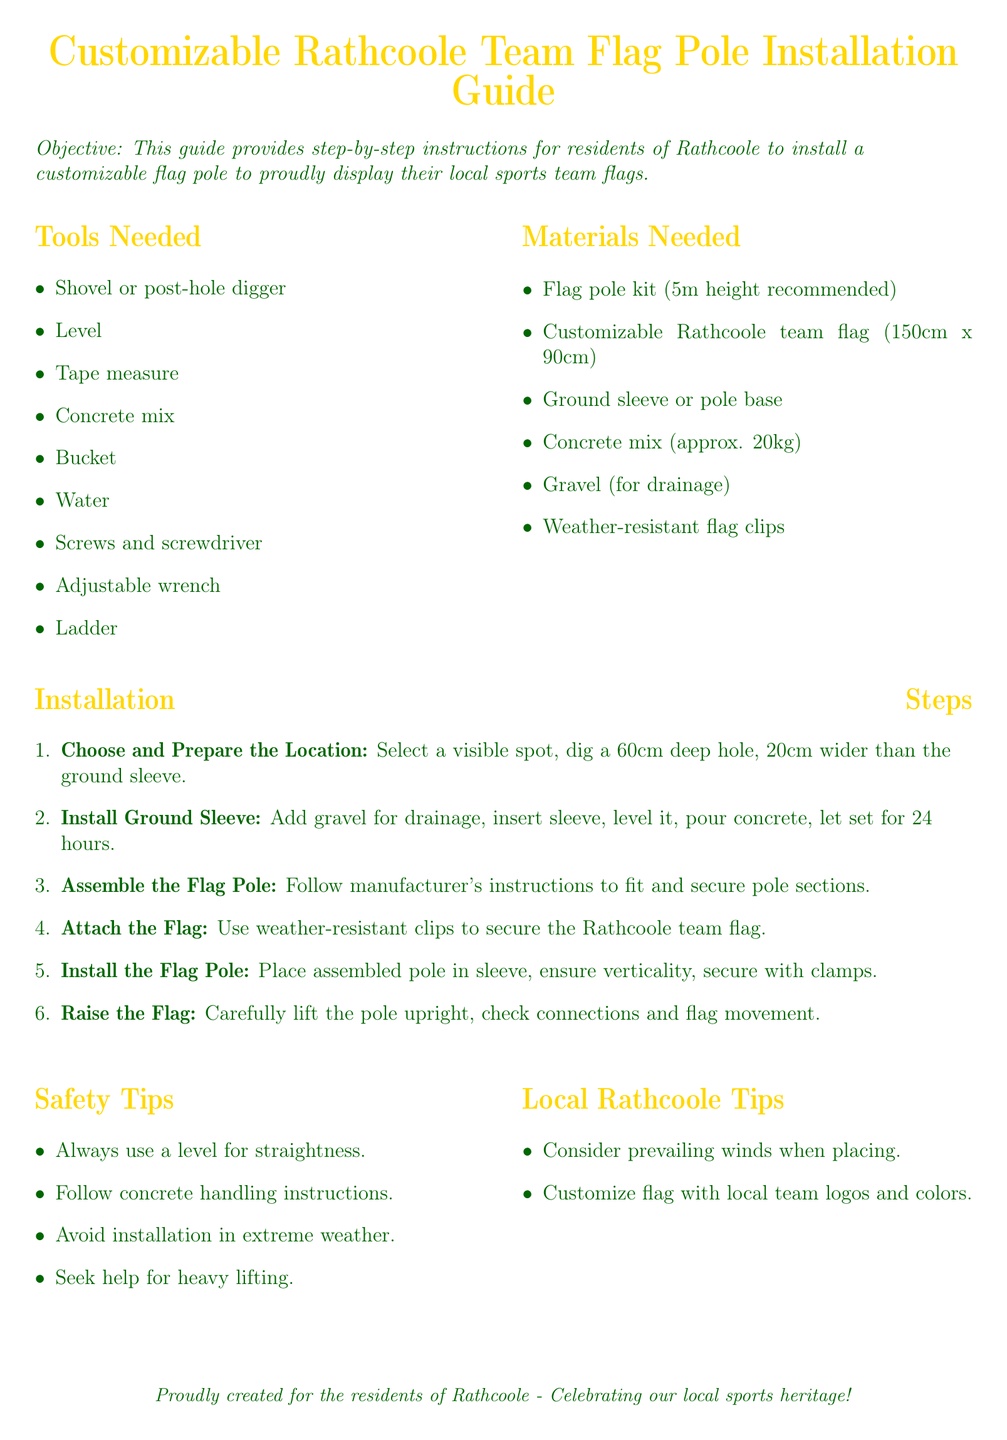What is the height of the recommended flag pole? The document specifies a flag pole height of 5m, which is recommended for installation.
Answer: 5m How deep should the hole be for the ground sleeve? The instructions indicate that the hole should be 60cm deep for the installation of the ground sleeve.
Answer: 60cm What is the size of the customizable Rathcoole team flag? The flag dimensions provided in the document are 150cm x 90cm for the customizable team flag.
Answer: 150cm x 90cm What should be added for drainage before installing the ground sleeve? The guide suggests adding gravel for drainage before inserting the ground sleeve in the hole.
Answer: Gravel How long should the concrete set after installing the ground sleeve? The document states that the concrete should be allowed to set for 24 hours after pouring.
Answer: 24 hours What tool is needed to ensure the flag pole is straight during installation? For ensuring straightness, the document recommends using a level during the installation process.
Answer: Level What types of weather conditions should be avoided during installation? The safety tips section advises avoiding installation in extreme weather conditions.
Answer: Extreme weather What customization is suggested for the flag? The local tips section mentions customizing the flag with local team logos and colors.
Answer: Local team logos and colors What materials are needed for drainage? The document specifies the need for gravel as a material for drainage during installation.
Answer: Gravel 